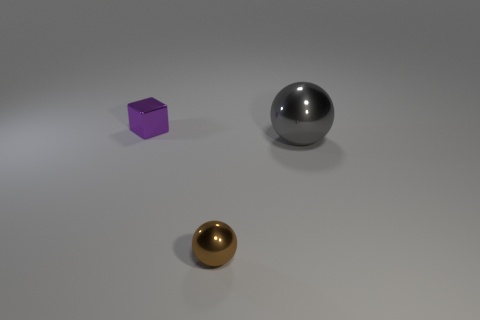What is the size of the object in front of the large ball?
Provide a succinct answer. Small. Are there any metal blocks in front of the tiny object in front of the metal block?
Ensure brevity in your answer.  No. Does the tiny thing right of the small block have the same material as the big gray thing?
Give a very brief answer. Yes. How many things are to the left of the tiny brown thing and right of the small ball?
Your answer should be compact. 0. What number of other brown things are made of the same material as the big object?
Provide a succinct answer. 1. There is a block that is the same material as the brown object; what is its color?
Offer a terse response. Purple. Is the number of tiny metal things less than the number of small blue rubber objects?
Provide a short and direct response. No. What is the material of the thing in front of the metallic thing that is to the right of the ball on the left side of the big gray metal sphere?
Provide a short and direct response. Metal. Is the number of big metal things greater than the number of small things?
Your answer should be compact. No. How many big objects are the same color as the cube?
Your answer should be compact. 0. 